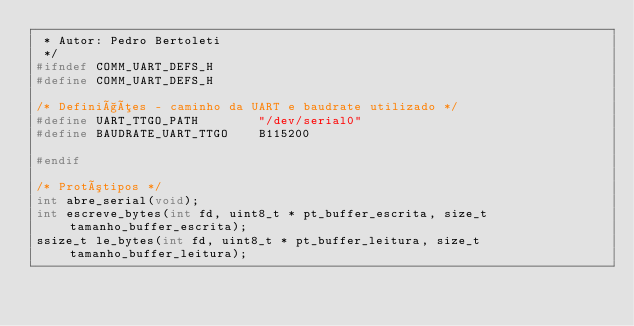<code> <loc_0><loc_0><loc_500><loc_500><_C_> * Autor: Pedro Bertoleti 
 */
#ifndef COMM_UART_DEFS_H
#define COMM_UART_DEFS_H

/* Definições - caminho da UART e baudrate utilizado */
#define UART_TTGO_PATH        "/dev/serial0"
#define BAUDRATE_UART_TTGO    B115200

#endif

/* Protótipos */
int abre_serial(void);
int escreve_bytes(int fd, uint8_t * pt_buffer_escrita, size_t tamanho_buffer_escrita);
ssize_t le_bytes(int fd, uint8_t * pt_buffer_leitura, size_t tamanho_buffer_leitura);</code> 